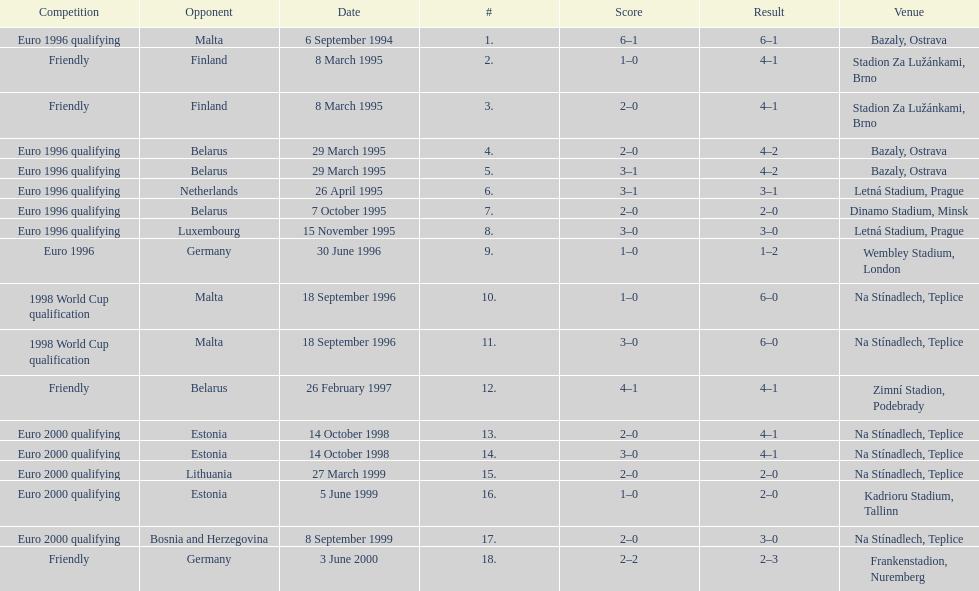List the opponent in which the result was the least out of all the results. Germany. 